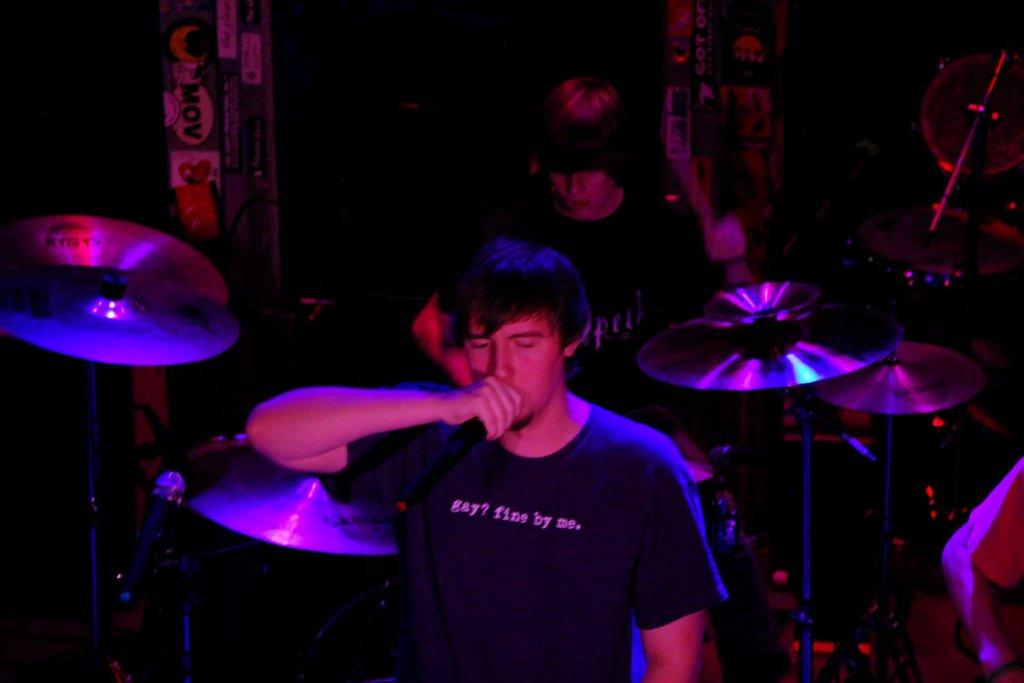How many people are present in the image? There are two people in the image. What are the people doing in the image? The people are playing musical instruments in the image. What objects are present that might be used for amplifying sound? There are microphones in the image. What can be observed about the lighting in the image? The background of the image is dark. What type of heart is visible in the image? There is no heart present in the image. What is the son doing in the image? There is no son present in the image. 